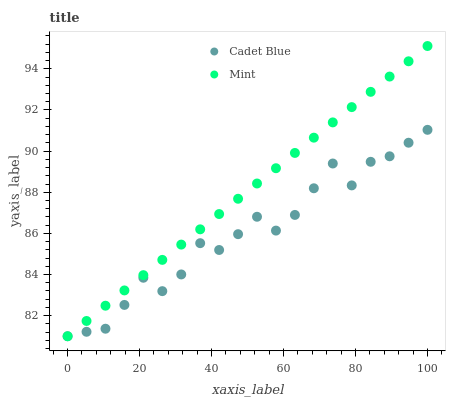Does Cadet Blue have the minimum area under the curve?
Answer yes or no. Yes. Does Mint have the maximum area under the curve?
Answer yes or no. Yes. Does Mint have the minimum area under the curve?
Answer yes or no. No. Is Mint the smoothest?
Answer yes or no. Yes. Is Cadet Blue the roughest?
Answer yes or no. Yes. Is Mint the roughest?
Answer yes or no. No. Does Cadet Blue have the lowest value?
Answer yes or no. Yes. Does Mint have the highest value?
Answer yes or no. Yes. Does Mint intersect Cadet Blue?
Answer yes or no. Yes. Is Mint less than Cadet Blue?
Answer yes or no. No. Is Mint greater than Cadet Blue?
Answer yes or no. No. 